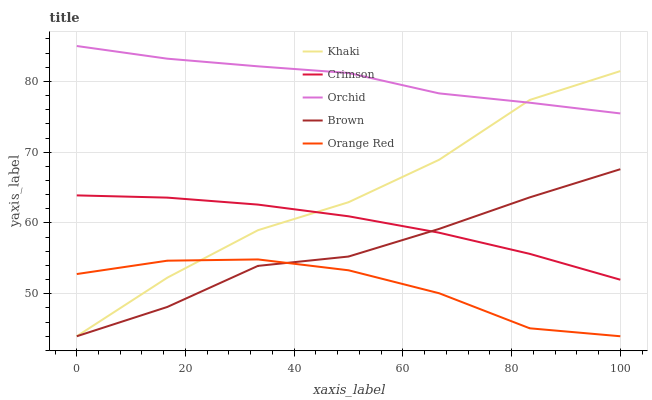Does Orange Red have the minimum area under the curve?
Answer yes or no. Yes. Does Orchid have the maximum area under the curve?
Answer yes or no. Yes. Does Brown have the minimum area under the curve?
Answer yes or no. No. Does Brown have the maximum area under the curve?
Answer yes or no. No. Is Crimson the smoothest?
Answer yes or no. Yes. Is Khaki the roughest?
Answer yes or no. Yes. Is Brown the smoothest?
Answer yes or no. No. Is Brown the roughest?
Answer yes or no. No. Does Brown have the lowest value?
Answer yes or no. Yes. Does Orchid have the lowest value?
Answer yes or no. No. Does Orchid have the highest value?
Answer yes or no. Yes. Does Brown have the highest value?
Answer yes or no. No. Is Orange Red less than Orchid?
Answer yes or no. Yes. Is Orchid greater than Orange Red?
Answer yes or no. Yes. Does Orchid intersect Khaki?
Answer yes or no. Yes. Is Orchid less than Khaki?
Answer yes or no. No. Is Orchid greater than Khaki?
Answer yes or no. No. Does Orange Red intersect Orchid?
Answer yes or no. No. 